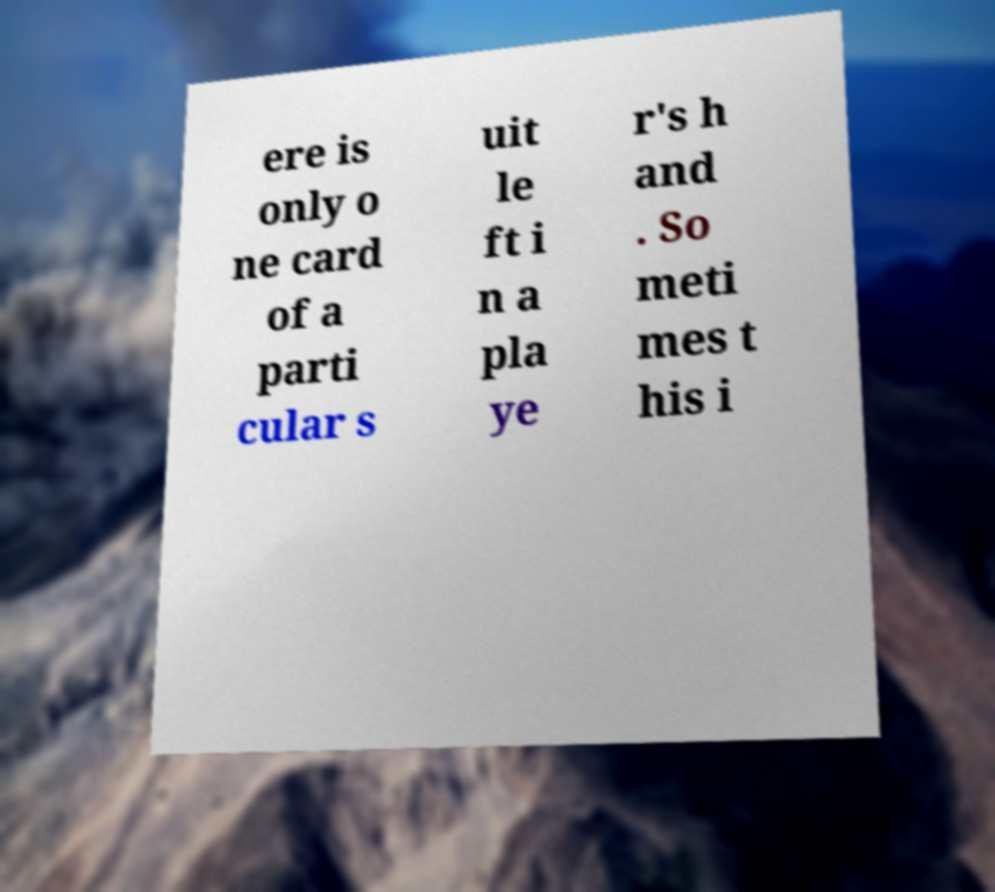Please identify and transcribe the text found in this image. ere is only o ne card of a parti cular s uit le ft i n a pla ye r's h and . So meti mes t his i 